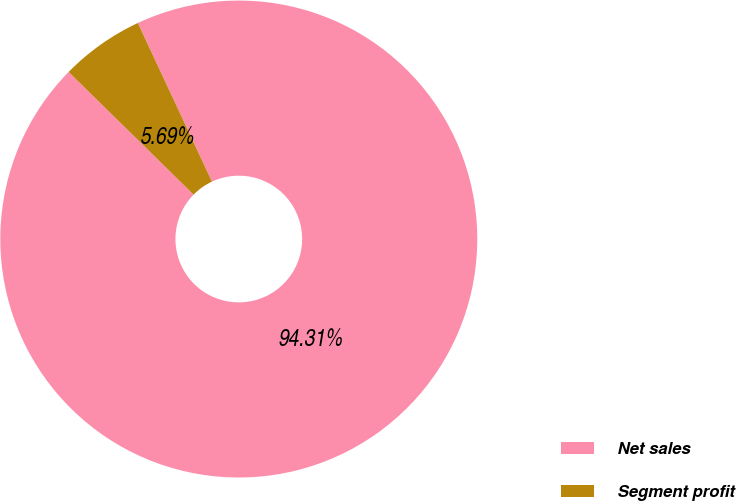Convert chart. <chart><loc_0><loc_0><loc_500><loc_500><pie_chart><fcel>Net sales<fcel>Segment profit<nl><fcel>94.31%<fcel>5.69%<nl></chart> 